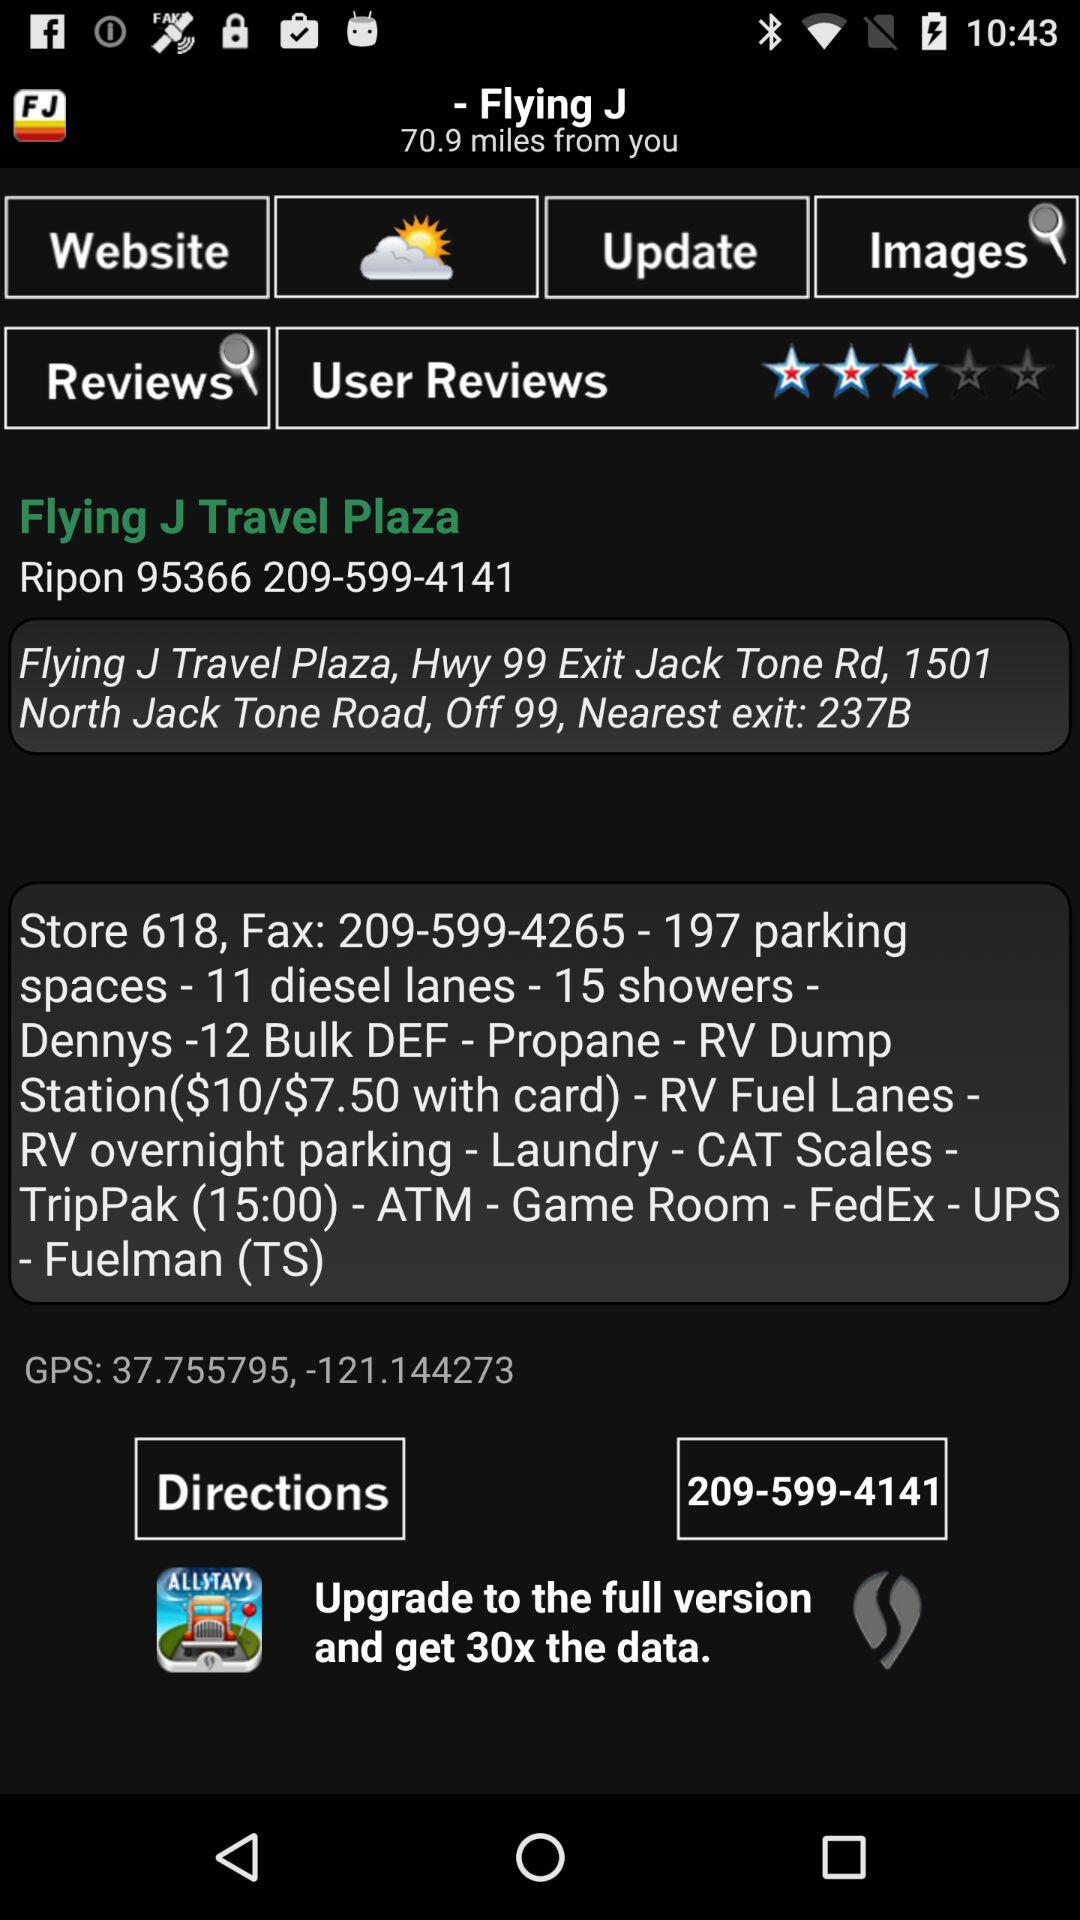What is the phone number? The phone number is 209-599-4141. 